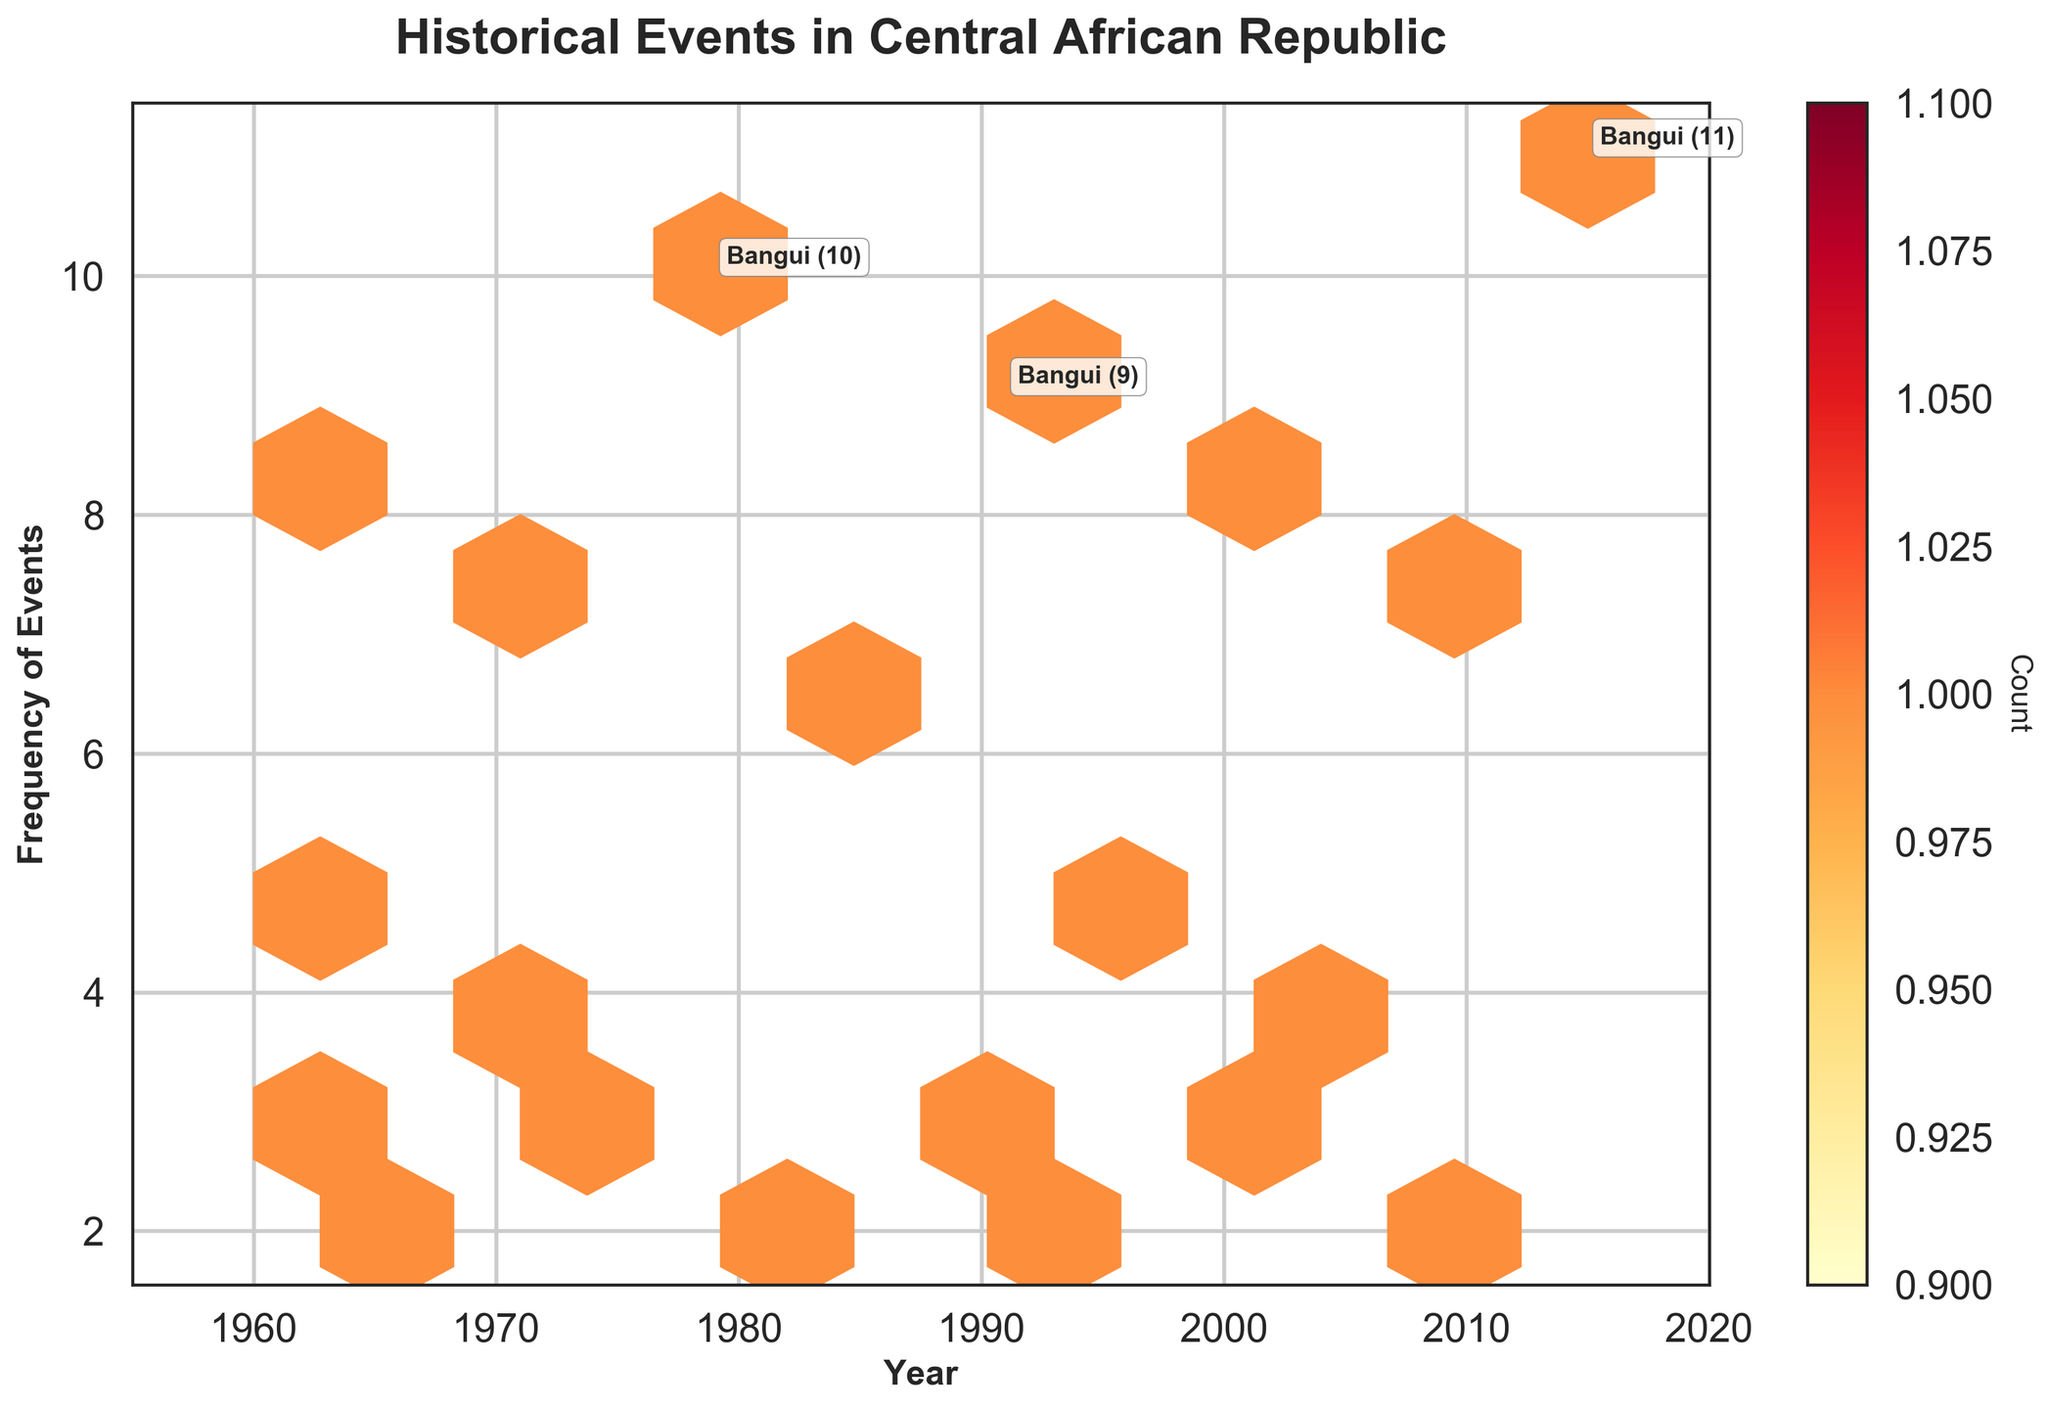What is the title of the plot? The title of the plot is displayed at the top of the figure in a large, bold font. It reads, "Historical Events in Central African Republic".
Answer: Historical Events in Central African Republic What does the color scale represent? The color scale, represented by yellow to red colors, indicates the count of data points within each hexbin. Brighter colors like yellow represent fewer data points, while darker colors like red represent more data points.
Answer: Count of data points How many key events had a frequency greater than 8? By looking at the annotations on the plot, you can see the locations marked with (Bangui 10), (Bangui 9), (Bangui 11). Counting these, there are three key events with a frequency greater than 8.
Answer: Three Which year had the highest frequency of historical events in Bangui? By observing the annotations and the frequencies listed, the year 2015 had a frequency of 11, which is the highest for historical events in Bangui.
Answer: 2015 In which year did Bangui experience the lowest recorded historical event frequency? Among the years Bangui is annotated, the year 1965 had the lowest frequency of 5, according to the annotations.
Answer: 1965 What years are displayed on the x-axis? The x-axis, representing "Year", has ticks from 1960 to 2020, marked at intervals of 10 years (1960, 1970, 1980, 1990, 2000, 2010, 2020).
Answer: 1960 to 2020 Which location had a historical event frequency of 3 in 1999? By referring to the annotations on the plot and matching the year and frequency, the location with a frequency of 3 in 1999 is Carnot.
Answer: Carnot Between which years did the figure record the most frequent historical events? By observing the density of hexagons and the annotations, the most frequent historical events occurred primarily around the years 1979, 1991, 2003, 2009, and 2015, all prominently highlighting Bangui.
Answer: Around 1979, 1991, 2003, 2009, 2015 Which location outside of Bangui had events with a frequency greater than 4? Among the annotated events, outside of Bangui, the location Bimbo in 2006 had a recorded frequency of 4.
Answer: Bimbo What is the range of frequencies shown on the y-axis? The y-axis, representing "Frequency of Events", ranges from 0 to 12, as annotated by the axis ticks.
Answer: 0 to 12 